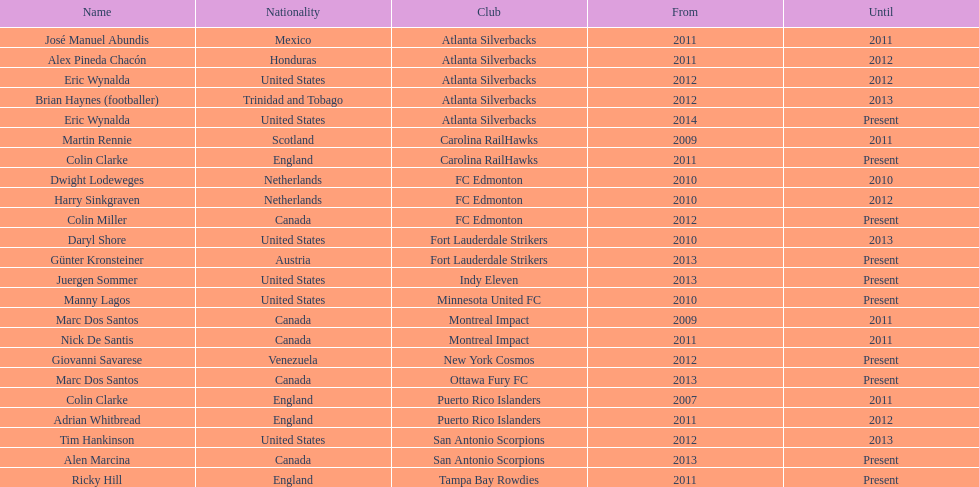How many coaches on the list have canadian origins? 5. 